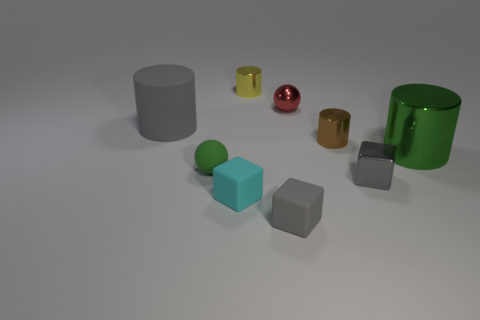Is the color of the large matte object the same as the tiny shiny block?
Make the answer very short. Yes. Is the number of green things right of the small cyan thing greater than the number of large purple metallic cylinders?
Provide a short and direct response. Yes. What is the shape of the large object that is to the right of the gray cube left of the tiny sphere right of the tiny yellow object?
Make the answer very short. Cylinder. Is the shape of the gray matte thing that is in front of the cyan cube the same as the small metallic thing in front of the green cylinder?
Your response must be concise. Yes. How many blocks are tiny gray metal things or tiny gray things?
Your answer should be very brief. 2. Are the brown cylinder and the cyan object made of the same material?
Your answer should be compact. No. How many other objects are the same color as the large shiny cylinder?
Provide a short and direct response. 1. What is the shape of the green object that is on the left side of the brown shiny thing?
Your answer should be very brief. Sphere. What number of things are small brown cylinders or big blue metal things?
Provide a succinct answer. 1. Do the brown metal cylinder and the green object on the left side of the small red metal ball have the same size?
Ensure brevity in your answer.  Yes. 